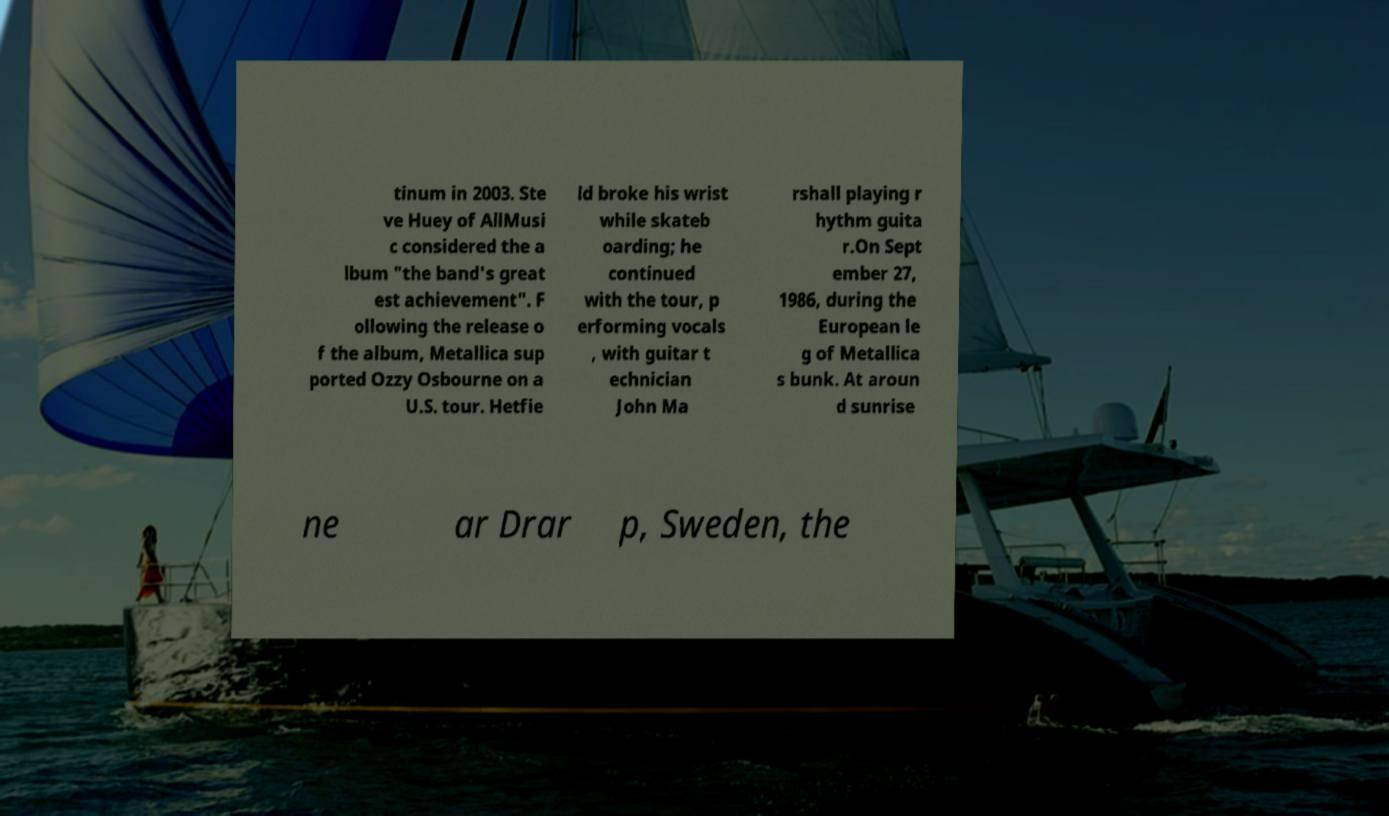Please read and relay the text visible in this image. What does it say? tinum in 2003. Ste ve Huey of AllMusi c considered the a lbum "the band's great est achievement". F ollowing the release o f the album, Metallica sup ported Ozzy Osbourne on a U.S. tour. Hetfie ld broke his wrist while skateb oarding; he continued with the tour, p erforming vocals , with guitar t echnician John Ma rshall playing r hythm guita r.On Sept ember 27, 1986, during the European le g of Metallica s bunk. At aroun d sunrise ne ar Drar p, Sweden, the 